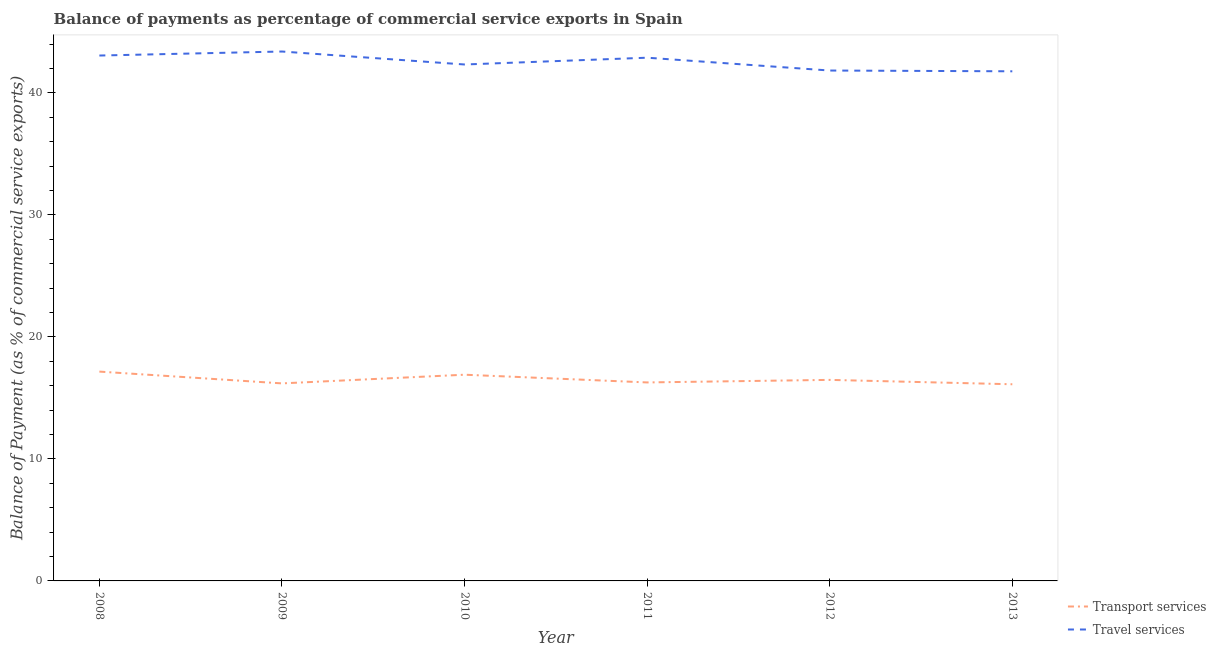How many different coloured lines are there?
Offer a terse response. 2. What is the balance of payments of travel services in 2013?
Provide a short and direct response. 41.78. Across all years, what is the maximum balance of payments of travel services?
Your answer should be very brief. 43.4. Across all years, what is the minimum balance of payments of travel services?
Offer a very short reply. 41.78. What is the total balance of payments of transport services in the graph?
Your answer should be compact. 99.13. What is the difference between the balance of payments of transport services in 2008 and that in 2009?
Keep it short and to the point. 0.97. What is the difference between the balance of payments of transport services in 2013 and the balance of payments of travel services in 2009?
Offer a very short reply. -27.28. What is the average balance of payments of transport services per year?
Ensure brevity in your answer.  16.52. In the year 2008, what is the difference between the balance of payments of transport services and balance of payments of travel services?
Keep it short and to the point. -25.91. What is the ratio of the balance of payments of transport services in 2008 to that in 2011?
Offer a very short reply. 1.05. Is the balance of payments of transport services in 2008 less than that in 2012?
Give a very brief answer. No. Is the difference between the balance of payments of transport services in 2008 and 2011 greater than the difference between the balance of payments of travel services in 2008 and 2011?
Your answer should be compact. Yes. What is the difference between the highest and the second highest balance of payments of transport services?
Ensure brevity in your answer.  0.26. What is the difference between the highest and the lowest balance of payments of transport services?
Provide a short and direct response. 1.04. In how many years, is the balance of payments of travel services greater than the average balance of payments of travel services taken over all years?
Give a very brief answer. 3. Is the sum of the balance of payments of transport services in 2012 and 2013 greater than the maximum balance of payments of travel services across all years?
Your response must be concise. No. Does the balance of payments of transport services monotonically increase over the years?
Ensure brevity in your answer.  No. Is the balance of payments of travel services strictly greater than the balance of payments of transport services over the years?
Offer a very short reply. Yes. Is the balance of payments of transport services strictly less than the balance of payments of travel services over the years?
Offer a very short reply. Yes. How many lines are there?
Give a very brief answer. 2. What is the difference between two consecutive major ticks on the Y-axis?
Ensure brevity in your answer.  10. Where does the legend appear in the graph?
Offer a terse response. Bottom right. What is the title of the graph?
Keep it short and to the point. Balance of payments as percentage of commercial service exports in Spain. What is the label or title of the X-axis?
Your answer should be very brief. Year. What is the label or title of the Y-axis?
Give a very brief answer. Balance of Payment (as % of commercial service exports). What is the Balance of Payment (as % of commercial service exports) in Transport services in 2008?
Your answer should be compact. 17.16. What is the Balance of Payment (as % of commercial service exports) of Travel services in 2008?
Give a very brief answer. 43.07. What is the Balance of Payment (as % of commercial service exports) in Transport services in 2009?
Provide a short and direct response. 16.19. What is the Balance of Payment (as % of commercial service exports) of Travel services in 2009?
Offer a very short reply. 43.4. What is the Balance of Payment (as % of commercial service exports) of Transport services in 2010?
Provide a short and direct response. 16.9. What is the Balance of Payment (as % of commercial service exports) in Travel services in 2010?
Give a very brief answer. 42.33. What is the Balance of Payment (as % of commercial service exports) of Transport services in 2011?
Your answer should be very brief. 16.27. What is the Balance of Payment (as % of commercial service exports) of Travel services in 2011?
Make the answer very short. 42.89. What is the Balance of Payment (as % of commercial service exports) in Transport services in 2012?
Your answer should be compact. 16.48. What is the Balance of Payment (as % of commercial service exports) in Travel services in 2012?
Your answer should be very brief. 41.84. What is the Balance of Payment (as % of commercial service exports) in Transport services in 2013?
Ensure brevity in your answer.  16.12. What is the Balance of Payment (as % of commercial service exports) of Travel services in 2013?
Make the answer very short. 41.78. Across all years, what is the maximum Balance of Payment (as % of commercial service exports) of Transport services?
Provide a short and direct response. 17.16. Across all years, what is the maximum Balance of Payment (as % of commercial service exports) of Travel services?
Give a very brief answer. 43.4. Across all years, what is the minimum Balance of Payment (as % of commercial service exports) in Transport services?
Offer a terse response. 16.12. Across all years, what is the minimum Balance of Payment (as % of commercial service exports) in Travel services?
Make the answer very short. 41.78. What is the total Balance of Payment (as % of commercial service exports) of Transport services in the graph?
Offer a terse response. 99.13. What is the total Balance of Payment (as % of commercial service exports) in Travel services in the graph?
Your response must be concise. 255.3. What is the difference between the Balance of Payment (as % of commercial service exports) of Transport services in 2008 and that in 2009?
Give a very brief answer. 0.97. What is the difference between the Balance of Payment (as % of commercial service exports) in Travel services in 2008 and that in 2009?
Ensure brevity in your answer.  -0.33. What is the difference between the Balance of Payment (as % of commercial service exports) of Transport services in 2008 and that in 2010?
Your answer should be compact. 0.26. What is the difference between the Balance of Payment (as % of commercial service exports) of Travel services in 2008 and that in 2010?
Offer a very short reply. 0.73. What is the difference between the Balance of Payment (as % of commercial service exports) in Transport services in 2008 and that in 2011?
Provide a short and direct response. 0.89. What is the difference between the Balance of Payment (as % of commercial service exports) in Travel services in 2008 and that in 2011?
Your answer should be compact. 0.18. What is the difference between the Balance of Payment (as % of commercial service exports) in Transport services in 2008 and that in 2012?
Your response must be concise. 0.68. What is the difference between the Balance of Payment (as % of commercial service exports) of Travel services in 2008 and that in 2012?
Give a very brief answer. 1.23. What is the difference between the Balance of Payment (as % of commercial service exports) in Transport services in 2008 and that in 2013?
Ensure brevity in your answer.  1.04. What is the difference between the Balance of Payment (as % of commercial service exports) of Travel services in 2008 and that in 2013?
Your answer should be compact. 1.29. What is the difference between the Balance of Payment (as % of commercial service exports) in Transport services in 2009 and that in 2010?
Provide a succinct answer. -0.71. What is the difference between the Balance of Payment (as % of commercial service exports) of Travel services in 2009 and that in 2010?
Make the answer very short. 1.06. What is the difference between the Balance of Payment (as % of commercial service exports) of Transport services in 2009 and that in 2011?
Offer a terse response. -0.08. What is the difference between the Balance of Payment (as % of commercial service exports) of Travel services in 2009 and that in 2011?
Ensure brevity in your answer.  0.51. What is the difference between the Balance of Payment (as % of commercial service exports) of Transport services in 2009 and that in 2012?
Provide a succinct answer. -0.29. What is the difference between the Balance of Payment (as % of commercial service exports) in Travel services in 2009 and that in 2012?
Provide a succinct answer. 1.56. What is the difference between the Balance of Payment (as % of commercial service exports) in Transport services in 2009 and that in 2013?
Your response must be concise. 0.07. What is the difference between the Balance of Payment (as % of commercial service exports) of Travel services in 2009 and that in 2013?
Keep it short and to the point. 1.62. What is the difference between the Balance of Payment (as % of commercial service exports) of Transport services in 2010 and that in 2011?
Make the answer very short. 0.63. What is the difference between the Balance of Payment (as % of commercial service exports) in Travel services in 2010 and that in 2011?
Make the answer very short. -0.56. What is the difference between the Balance of Payment (as % of commercial service exports) in Transport services in 2010 and that in 2012?
Offer a terse response. 0.42. What is the difference between the Balance of Payment (as % of commercial service exports) in Travel services in 2010 and that in 2012?
Ensure brevity in your answer.  0.5. What is the difference between the Balance of Payment (as % of commercial service exports) in Transport services in 2010 and that in 2013?
Your answer should be very brief. 0.78. What is the difference between the Balance of Payment (as % of commercial service exports) of Travel services in 2010 and that in 2013?
Your answer should be compact. 0.56. What is the difference between the Balance of Payment (as % of commercial service exports) of Transport services in 2011 and that in 2012?
Offer a terse response. -0.21. What is the difference between the Balance of Payment (as % of commercial service exports) in Travel services in 2011 and that in 2012?
Provide a succinct answer. 1.05. What is the difference between the Balance of Payment (as % of commercial service exports) of Transport services in 2011 and that in 2013?
Keep it short and to the point. 0.15. What is the difference between the Balance of Payment (as % of commercial service exports) of Travel services in 2011 and that in 2013?
Offer a terse response. 1.11. What is the difference between the Balance of Payment (as % of commercial service exports) in Transport services in 2012 and that in 2013?
Make the answer very short. 0.36. What is the difference between the Balance of Payment (as % of commercial service exports) of Travel services in 2012 and that in 2013?
Keep it short and to the point. 0.06. What is the difference between the Balance of Payment (as % of commercial service exports) of Transport services in 2008 and the Balance of Payment (as % of commercial service exports) of Travel services in 2009?
Offer a very short reply. -26.24. What is the difference between the Balance of Payment (as % of commercial service exports) of Transport services in 2008 and the Balance of Payment (as % of commercial service exports) of Travel services in 2010?
Provide a succinct answer. -25.17. What is the difference between the Balance of Payment (as % of commercial service exports) of Transport services in 2008 and the Balance of Payment (as % of commercial service exports) of Travel services in 2011?
Offer a very short reply. -25.73. What is the difference between the Balance of Payment (as % of commercial service exports) of Transport services in 2008 and the Balance of Payment (as % of commercial service exports) of Travel services in 2012?
Your answer should be compact. -24.68. What is the difference between the Balance of Payment (as % of commercial service exports) in Transport services in 2008 and the Balance of Payment (as % of commercial service exports) in Travel services in 2013?
Your answer should be very brief. -24.62. What is the difference between the Balance of Payment (as % of commercial service exports) in Transport services in 2009 and the Balance of Payment (as % of commercial service exports) in Travel services in 2010?
Ensure brevity in your answer.  -26.14. What is the difference between the Balance of Payment (as % of commercial service exports) in Transport services in 2009 and the Balance of Payment (as % of commercial service exports) in Travel services in 2011?
Make the answer very short. -26.7. What is the difference between the Balance of Payment (as % of commercial service exports) in Transport services in 2009 and the Balance of Payment (as % of commercial service exports) in Travel services in 2012?
Offer a terse response. -25.65. What is the difference between the Balance of Payment (as % of commercial service exports) in Transport services in 2009 and the Balance of Payment (as % of commercial service exports) in Travel services in 2013?
Your response must be concise. -25.58. What is the difference between the Balance of Payment (as % of commercial service exports) in Transport services in 2010 and the Balance of Payment (as % of commercial service exports) in Travel services in 2011?
Give a very brief answer. -25.99. What is the difference between the Balance of Payment (as % of commercial service exports) of Transport services in 2010 and the Balance of Payment (as % of commercial service exports) of Travel services in 2012?
Your response must be concise. -24.93. What is the difference between the Balance of Payment (as % of commercial service exports) in Transport services in 2010 and the Balance of Payment (as % of commercial service exports) in Travel services in 2013?
Keep it short and to the point. -24.87. What is the difference between the Balance of Payment (as % of commercial service exports) of Transport services in 2011 and the Balance of Payment (as % of commercial service exports) of Travel services in 2012?
Your answer should be compact. -25.57. What is the difference between the Balance of Payment (as % of commercial service exports) in Transport services in 2011 and the Balance of Payment (as % of commercial service exports) in Travel services in 2013?
Ensure brevity in your answer.  -25.5. What is the difference between the Balance of Payment (as % of commercial service exports) of Transport services in 2012 and the Balance of Payment (as % of commercial service exports) of Travel services in 2013?
Your response must be concise. -25.3. What is the average Balance of Payment (as % of commercial service exports) in Transport services per year?
Your response must be concise. 16.52. What is the average Balance of Payment (as % of commercial service exports) of Travel services per year?
Give a very brief answer. 42.55. In the year 2008, what is the difference between the Balance of Payment (as % of commercial service exports) of Transport services and Balance of Payment (as % of commercial service exports) of Travel services?
Offer a terse response. -25.91. In the year 2009, what is the difference between the Balance of Payment (as % of commercial service exports) in Transport services and Balance of Payment (as % of commercial service exports) in Travel services?
Ensure brevity in your answer.  -27.2. In the year 2010, what is the difference between the Balance of Payment (as % of commercial service exports) in Transport services and Balance of Payment (as % of commercial service exports) in Travel services?
Your answer should be very brief. -25.43. In the year 2011, what is the difference between the Balance of Payment (as % of commercial service exports) of Transport services and Balance of Payment (as % of commercial service exports) of Travel services?
Offer a very short reply. -26.62. In the year 2012, what is the difference between the Balance of Payment (as % of commercial service exports) of Transport services and Balance of Payment (as % of commercial service exports) of Travel services?
Your answer should be very brief. -25.36. In the year 2013, what is the difference between the Balance of Payment (as % of commercial service exports) of Transport services and Balance of Payment (as % of commercial service exports) of Travel services?
Give a very brief answer. -25.66. What is the ratio of the Balance of Payment (as % of commercial service exports) of Transport services in 2008 to that in 2009?
Provide a short and direct response. 1.06. What is the ratio of the Balance of Payment (as % of commercial service exports) in Travel services in 2008 to that in 2009?
Your answer should be very brief. 0.99. What is the ratio of the Balance of Payment (as % of commercial service exports) in Transport services in 2008 to that in 2010?
Make the answer very short. 1.02. What is the ratio of the Balance of Payment (as % of commercial service exports) of Travel services in 2008 to that in 2010?
Give a very brief answer. 1.02. What is the ratio of the Balance of Payment (as % of commercial service exports) in Transport services in 2008 to that in 2011?
Your response must be concise. 1.05. What is the ratio of the Balance of Payment (as % of commercial service exports) in Travel services in 2008 to that in 2011?
Your response must be concise. 1. What is the ratio of the Balance of Payment (as % of commercial service exports) in Transport services in 2008 to that in 2012?
Give a very brief answer. 1.04. What is the ratio of the Balance of Payment (as % of commercial service exports) in Travel services in 2008 to that in 2012?
Keep it short and to the point. 1.03. What is the ratio of the Balance of Payment (as % of commercial service exports) in Transport services in 2008 to that in 2013?
Give a very brief answer. 1.06. What is the ratio of the Balance of Payment (as % of commercial service exports) of Travel services in 2008 to that in 2013?
Offer a very short reply. 1.03. What is the ratio of the Balance of Payment (as % of commercial service exports) of Transport services in 2009 to that in 2010?
Make the answer very short. 0.96. What is the ratio of the Balance of Payment (as % of commercial service exports) of Travel services in 2009 to that in 2010?
Give a very brief answer. 1.03. What is the ratio of the Balance of Payment (as % of commercial service exports) of Travel services in 2009 to that in 2011?
Ensure brevity in your answer.  1.01. What is the ratio of the Balance of Payment (as % of commercial service exports) of Transport services in 2009 to that in 2012?
Your response must be concise. 0.98. What is the ratio of the Balance of Payment (as % of commercial service exports) of Travel services in 2009 to that in 2012?
Make the answer very short. 1.04. What is the ratio of the Balance of Payment (as % of commercial service exports) in Transport services in 2009 to that in 2013?
Offer a very short reply. 1. What is the ratio of the Balance of Payment (as % of commercial service exports) of Travel services in 2009 to that in 2013?
Offer a terse response. 1.04. What is the ratio of the Balance of Payment (as % of commercial service exports) of Transport services in 2010 to that in 2011?
Provide a short and direct response. 1.04. What is the ratio of the Balance of Payment (as % of commercial service exports) in Travel services in 2010 to that in 2011?
Offer a terse response. 0.99. What is the ratio of the Balance of Payment (as % of commercial service exports) of Transport services in 2010 to that in 2012?
Offer a very short reply. 1.03. What is the ratio of the Balance of Payment (as % of commercial service exports) in Travel services in 2010 to that in 2012?
Make the answer very short. 1.01. What is the ratio of the Balance of Payment (as % of commercial service exports) of Transport services in 2010 to that in 2013?
Make the answer very short. 1.05. What is the ratio of the Balance of Payment (as % of commercial service exports) of Travel services in 2010 to that in 2013?
Keep it short and to the point. 1.01. What is the ratio of the Balance of Payment (as % of commercial service exports) of Transport services in 2011 to that in 2012?
Your answer should be very brief. 0.99. What is the ratio of the Balance of Payment (as % of commercial service exports) in Travel services in 2011 to that in 2012?
Ensure brevity in your answer.  1.03. What is the ratio of the Balance of Payment (as % of commercial service exports) of Transport services in 2011 to that in 2013?
Provide a short and direct response. 1.01. What is the ratio of the Balance of Payment (as % of commercial service exports) of Travel services in 2011 to that in 2013?
Provide a succinct answer. 1.03. What is the ratio of the Balance of Payment (as % of commercial service exports) of Transport services in 2012 to that in 2013?
Give a very brief answer. 1.02. What is the ratio of the Balance of Payment (as % of commercial service exports) in Travel services in 2012 to that in 2013?
Your response must be concise. 1. What is the difference between the highest and the second highest Balance of Payment (as % of commercial service exports) in Transport services?
Provide a short and direct response. 0.26. What is the difference between the highest and the second highest Balance of Payment (as % of commercial service exports) in Travel services?
Make the answer very short. 0.33. What is the difference between the highest and the lowest Balance of Payment (as % of commercial service exports) in Transport services?
Provide a succinct answer. 1.04. What is the difference between the highest and the lowest Balance of Payment (as % of commercial service exports) of Travel services?
Provide a succinct answer. 1.62. 